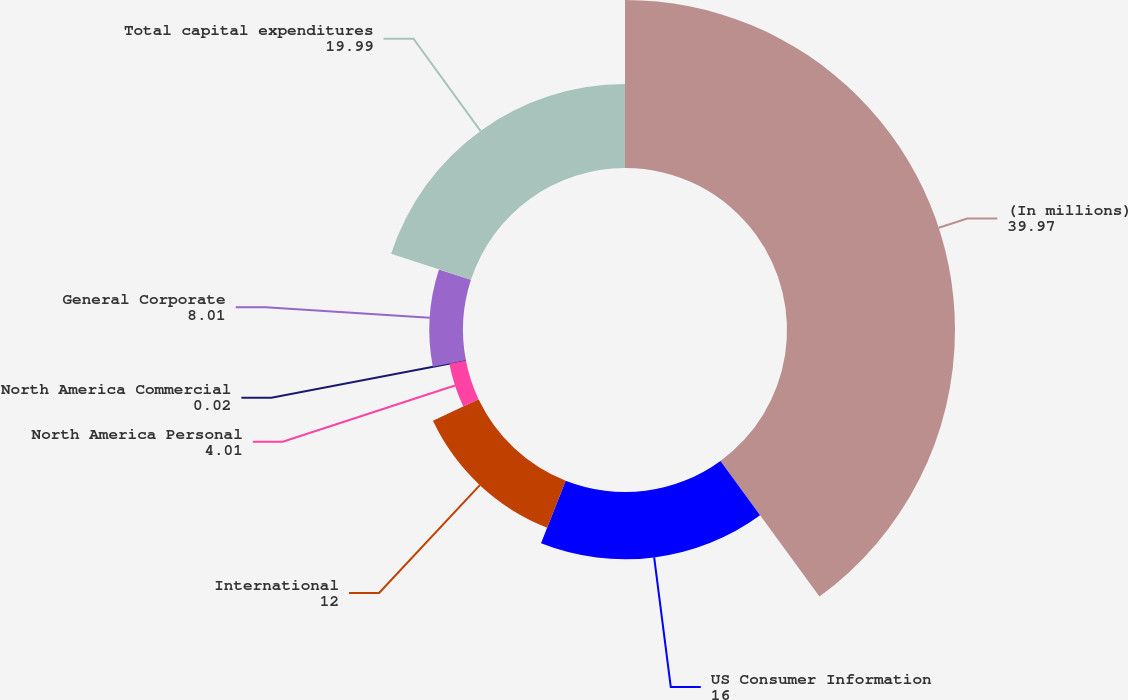Convert chart. <chart><loc_0><loc_0><loc_500><loc_500><pie_chart><fcel>(In millions)<fcel>US Consumer Information<fcel>International<fcel>North America Personal<fcel>North America Commercial<fcel>General Corporate<fcel>Total capital expenditures<nl><fcel>39.97%<fcel>16.0%<fcel>12.0%<fcel>4.01%<fcel>0.02%<fcel>8.01%<fcel>19.99%<nl></chart> 